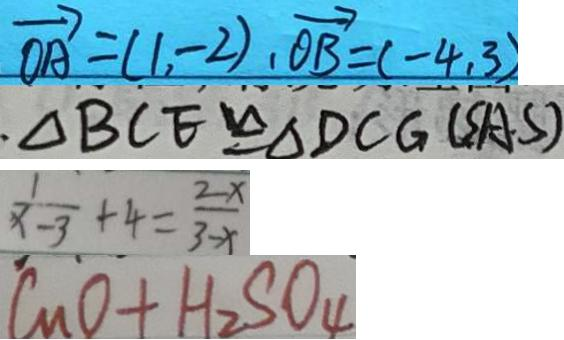Convert formula to latex. <formula><loc_0><loc_0><loc_500><loc_500>\overrightarrow { O A } = ( 1 , - 2 ) , \overrightarrow { O B } = ( - 4 , 3 ) 
 \Delta B C E \cong \Delta D C G ( S A S ) 
 \frac { 1 } { x - 3 } + 4 = \frac { 2 - x } { 3 - x } 
 C u O + H _ { 2 } S O _ { 4 }</formula> 